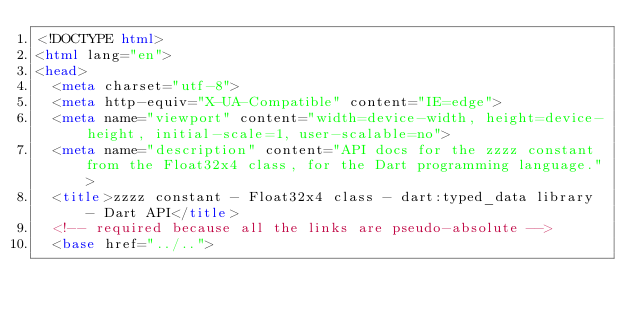<code> <loc_0><loc_0><loc_500><loc_500><_HTML_><!DOCTYPE html>
<html lang="en">
<head>
  <meta charset="utf-8">
  <meta http-equiv="X-UA-Compatible" content="IE=edge">
  <meta name="viewport" content="width=device-width, height=device-height, initial-scale=1, user-scalable=no">
  <meta name="description" content="API docs for the zzzz constant from the Float32x4 class, for the Dart programming language.">
  <title>zzzz constant - Float32x4 class - dart:typed_data library - Dart API</title>
  <!-- required because all the links are pseudo-absolute -->
  <base href="../..">
</code> 